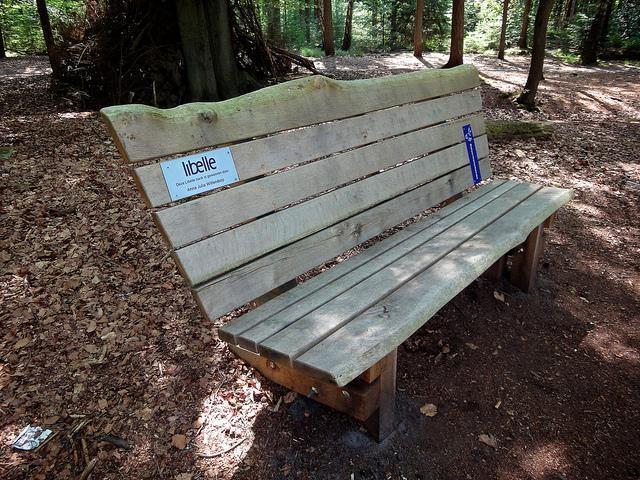How many legs are on the bench?
Give a very brief answer. 2. How many signs are on the bench?
Give a very brief answer. 2. 